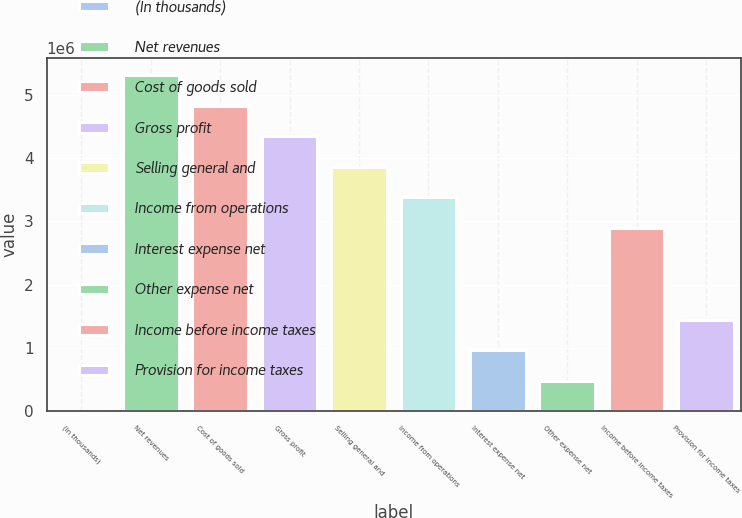<chart> <loc_0><loc_0><loc_500><loc_500><bar_chart><fcel>(In thousands)<fcel>Net revenues<fcel>Cost of goods sold<fcel>Gross profit<fcel>Selling general and<fcel>Income from operations<fcel>Interest expense net<fcel>Other expense net<fcel>Income before income taxes<fcel>Provision for income taxes<nl><fcel>2016<fcel>5.30767e+06<fcel>4.82534e+06<fcel>4.343e+06<fcel>3.86067e+06<fcel>3.37834e+06<fcel>966680<fcel>484348<fcel>2.89601e+06<fcel>1.44901e+06<nl></chart> 